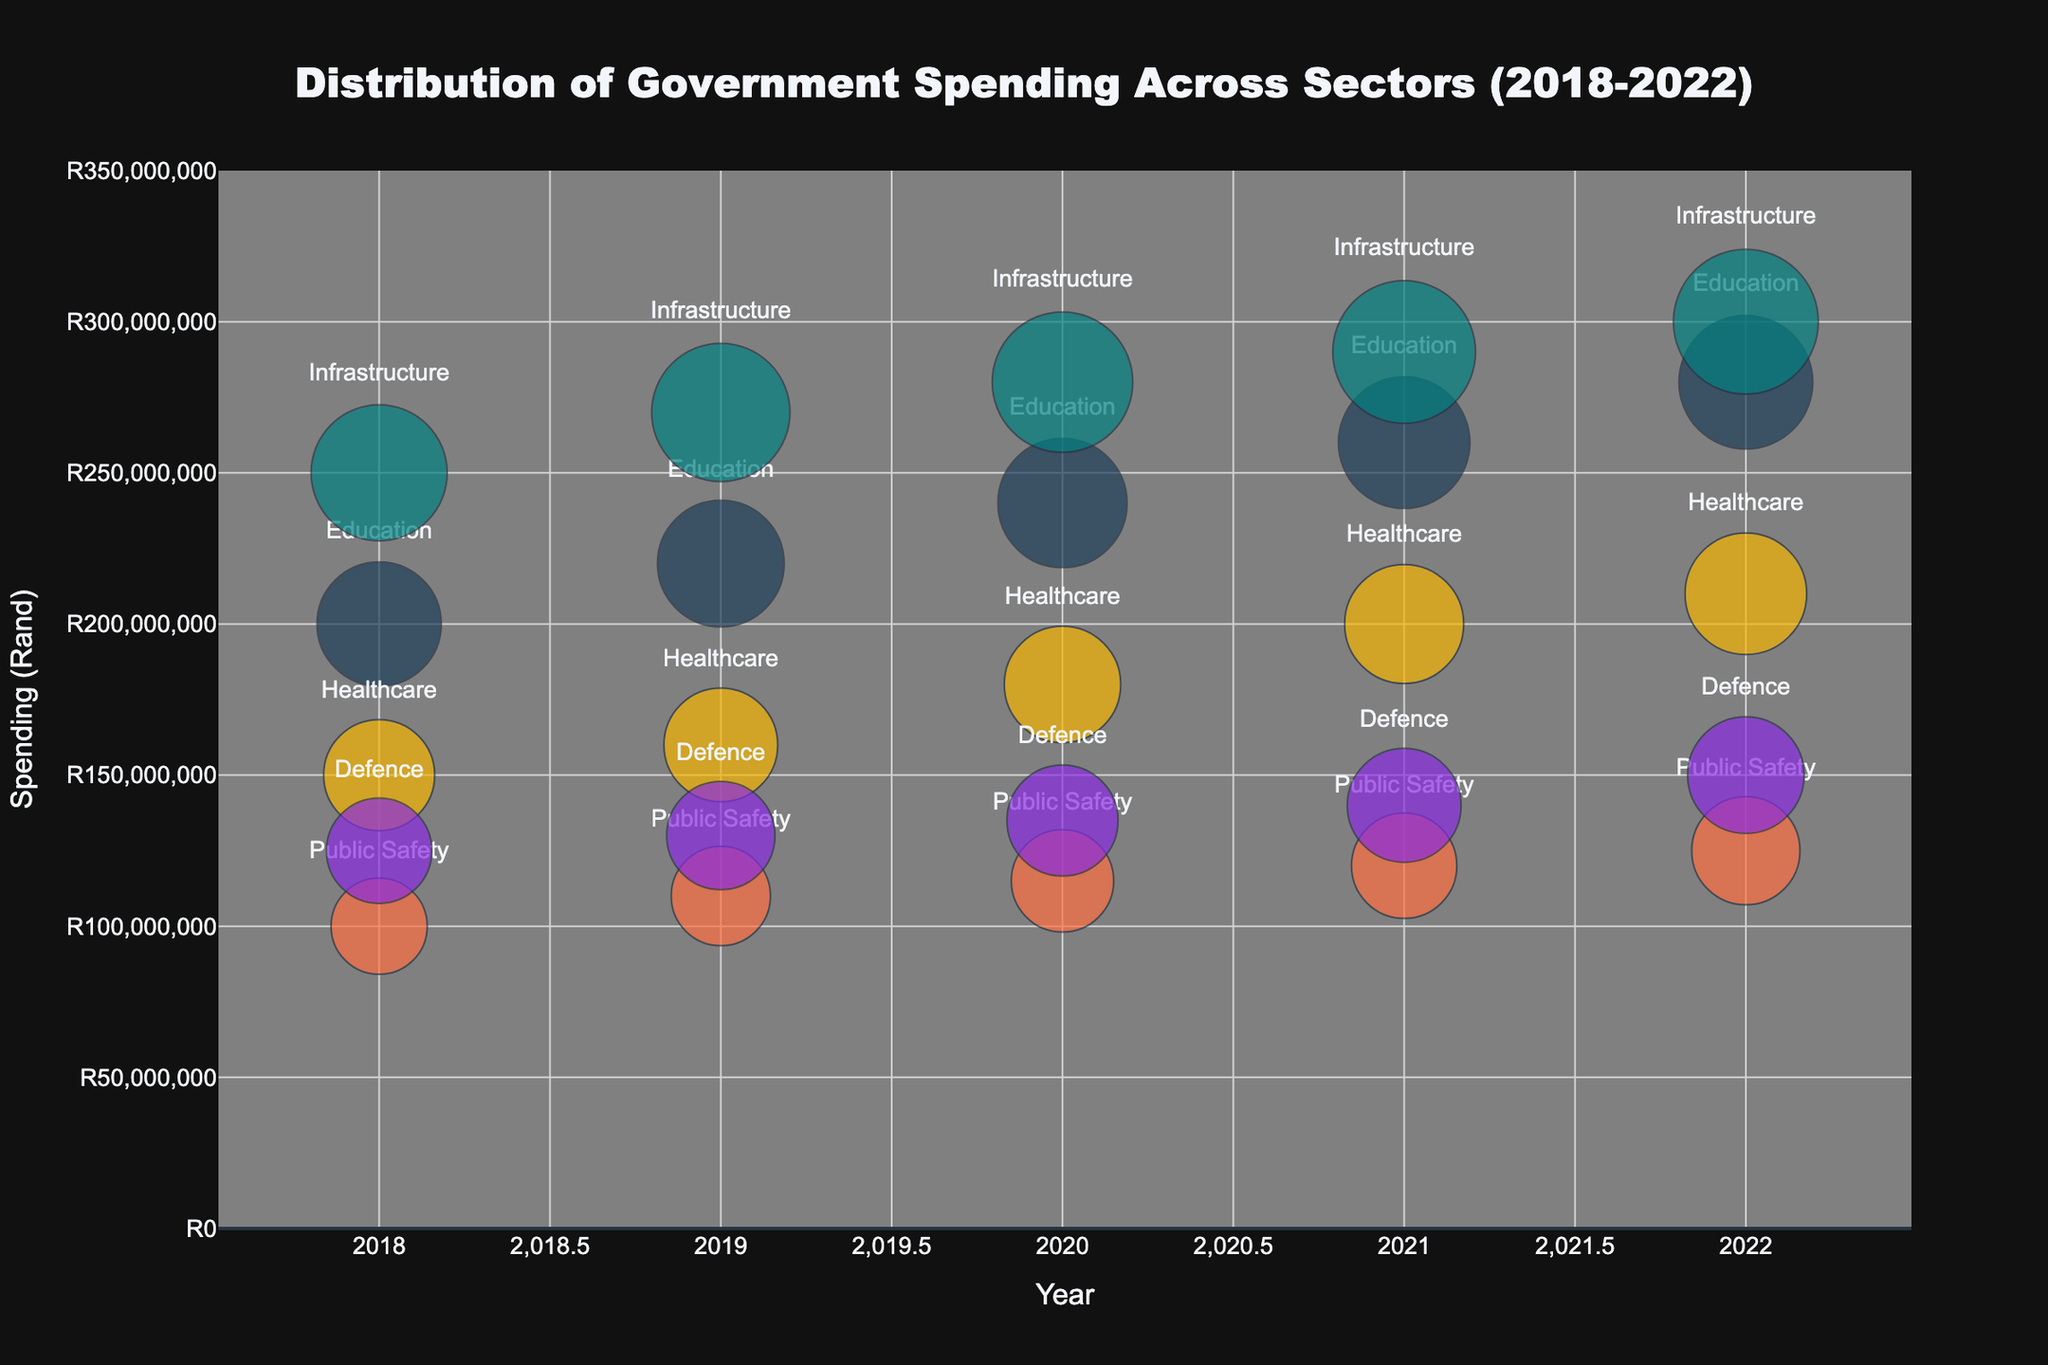What's the title of the chart? The title is displayed at the top of the chart. It reads "Distribution of Government Spending Across Sectors (2018-2022)".
Answer: Distribution of Government Spending Across Sectors (2018-2022) Which sector had the highest government spending in 2020? By looking at the bubble positions in 2020 along the y-axis, the highest positioned bubble represents Infrastructure.
Answer: Infrastructure How did the spending on Education change from 2018 to 2022? To determine the change, compare the y-axis values for Education bubbles from 2018 (R200,000,000) to 2022 (R280,000,000).
Answer: Increased by R80,000,000 What is the total government spending across all sectors in 2021? Sum the y-axis values of all sectors in 2021: Education (R260,000,000) + Healthcare (R200,000,000) + Public Safety (R120,000,000) + Infrastructure (R290,000,000) + Defence (R140,000,000).
Answer: R1,010,000,000 Which two sectors have the closest spending in 2022? Look at the bubbles in 2022 and compare their y-axis values. Healthcare (R210,000,000) and Defence (R150,000,000) are the closest.
Answer: Healthcare and Defence How does the size of the Healthcare bubble change from 2019 to 2021? Compare the bubble sizes (not positions) for Healthcare between 2019 (21) and 2021 (23).
Answer: Increased by 2 units In which year was the spending on Public Safety the lowest? Find the smallest y-axis value for Public Safety bubbles across all years. In 2018, it was R100,000,000.
Answer: 2018 Compare the growth in spending between Education and Healthcare from 2018 to 2022. Calculate the difference in spending for both sectors from 2018 to 2022. Education increased from R200,000,000 to R280,000,000, and Healthcare increased from R150,000,000 to R210,000,000. Education grew by R80,000,000 and Healthcare by R60,000,000.
Answer: Education grew more What is the average spending on Defence from 2018 to 2022? Average the y-axis values for Defence across these years: (R125,000,000 + R130,000,000 + R135,000,000 + R140,000,000 + R150,000,000) / 5.
Answer: R136,000,000 Which sector has the largest bubble size in 2020? Identify the biggest bubble in 2020 by size, not position. The largest is for Infrastructure (size 32).
Answer: Infrastructure 